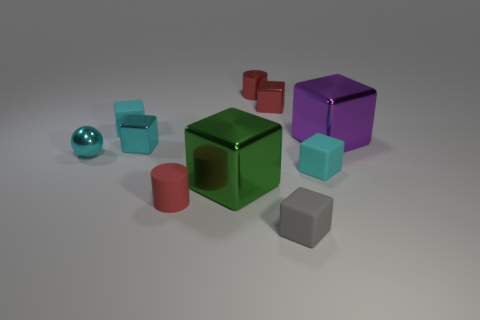Subtract all cyan blocks. How many were subtracted if there are1cyan blocks left? 2 Subtract all brown spheres. How many cyan blocks are left? 3 Subtract all purple cubes. How many cubes are left? 6 Subtract all large shiny cubes. How many cubes are left? 5 Subtract all gray cubes. Subtract all green balls. How many cubes are left? 6 Subtract all cylinders. How many objects are left? 8 Add 10 small blue shiny cylinders. How many small blue shiny cylinders exist? 10 Subtract 2 cyan blocks. How many objects are left? 8 Subtract all small gray rubber blocks. Subtract all large purple shiny things. How many objects are left? 8 Add 8 green metallic objects. How many green metallic objects are left? 9 